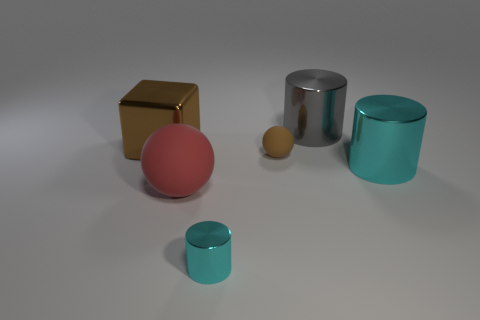Add 4 cyan shiny objects. How many objects exist? 10 Subtract all red spheres. How many spheres are left? 1 Subtract all big cylinders. How many cylinders are left? 1 Add 4 shiny cylinders. How many shiny cylinders are left? 7 Add 2 brown metallic objects. How many brown metallic objects exist? 3 Subtract 0 gray spheres. How many objects are left? 6 Subtract all balls. How many objects are left? 4 Subtract all yellow cylinders. Subtract all purple blocks. How many cylinders are left? 3 Subtract all green balls. How many green blocks are left? 0 Subtract all large brown blocks. Subtract all big balls. How many objects are left? 4 